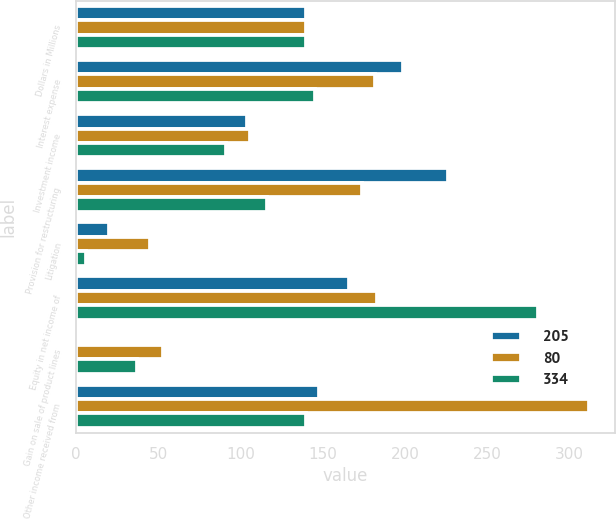Convert chart. <chart><loc_0><loc_0><loc_500><loc_500><stacked_bar_chart><ecel><fcel>Dollars in Millions<fcel>Interest expense<fcel>Investment income<fcel>Provision for restructuring<fcel>Litigation<fcel>Equity in net income of<fcel>Gain on sale of product lines<fcel>Other income received from<nl><fcel>205<fcel>140<fcel>199<fcel>104<fcel>226<fcel>20<fcel>166<fcel>2<fcel>148<nl><fcel>80<fcel>140<fcel>182<fcel>106<fcel>174<fcel>45<fcel>183<fcel>53<fcel>312<nl><fcel>334<fcel>140<fcel>145<fcel>91<fcel>116<fcel>6<fcel>281<fcel>37<fcel>140<nl></chart> 